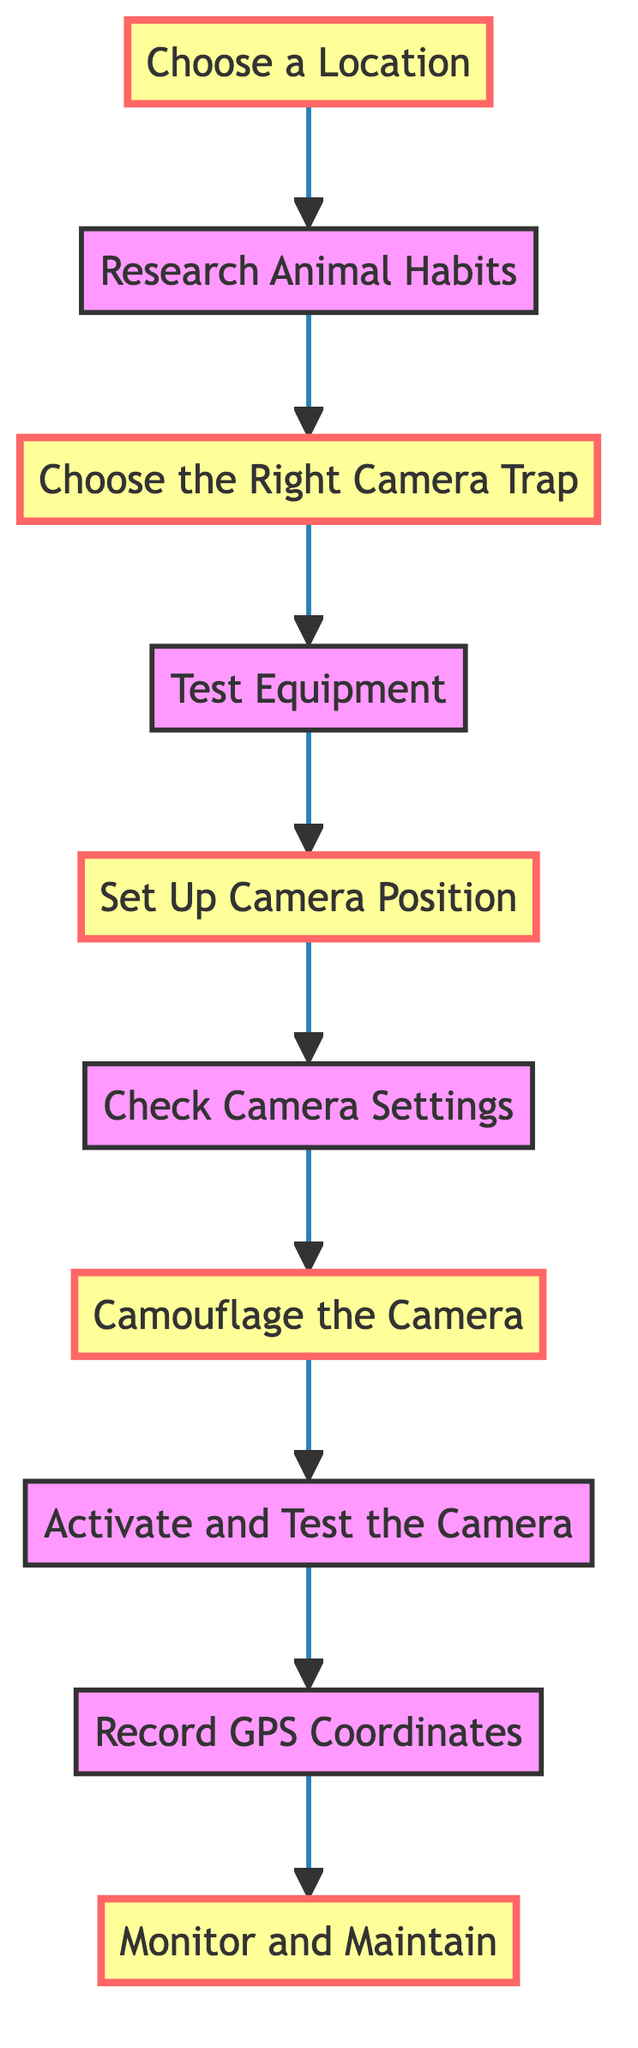What is the starting step in the process? The starting step is the first node in the diagram, which is "Choose a Location".
Answer: Choose a Location How many steps are there in total? By counting the nodes in the diagram, there are a total of 10 steps outlined from start to finish.
Answer: 10 Which step comes after "Research Animal Habits"? Referring to the flow of the diagram, the step that follows "Research Animal Habits" is "Choose the Right Camera Trap".
Answer: Choose the Right Camera Trap What is the final step in the process? The last step in the diagram, indicated by the final node, is "Monitor and Maintain".
Answer: Monitor and Maintain What actions are recommended to ensure camera functionality? The instructions suggest performing "Test Equipment" after choosing the camera trap and before setting up the camera position to ensure functionality.
Answer: Test Equipment What is the height recommended for setting up the camera? The description for "Set Up Camera Position" indicates that the camera should be positioned at a height of 1-2 feet off the ground.
Answer: 1-2 feet What should be done before activating the camera? Before activating the camera, it's essential to "Check Camera Settings" which involves configuring photo resolution and trigger sensitivity.
Answer: Check Camera Settings Why is camouflage important when setting up the camera? The diagram outlines "Camouflage the Camera" to help the camera blend into the surroundings without obstructing the lens, minimizing disturbance to wildlife.
Answer: Camouflage the Camera How often should the camera trap be monitored? The instructions under "Monitor and Maintain" imply regular checks, although they do not specify an exact frequency, it indicates an ongoing process.
Answer: Regularly 